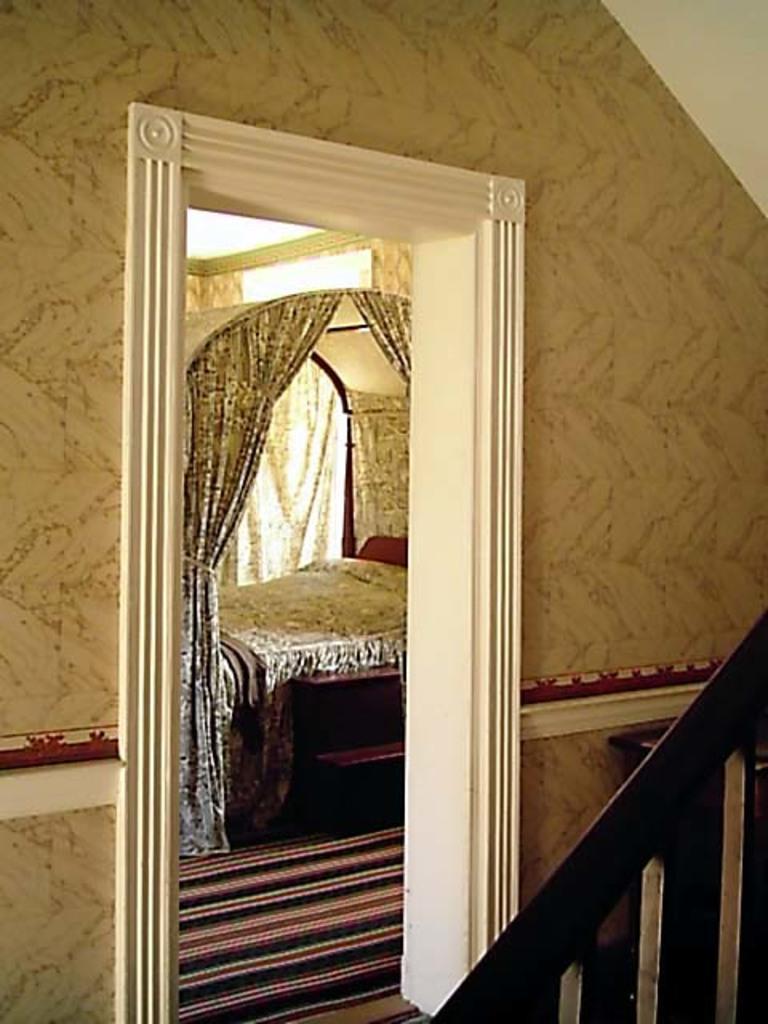How would you summarize this image in a sentence or two? In this picture I can see a bed, few curtains and a wall. 